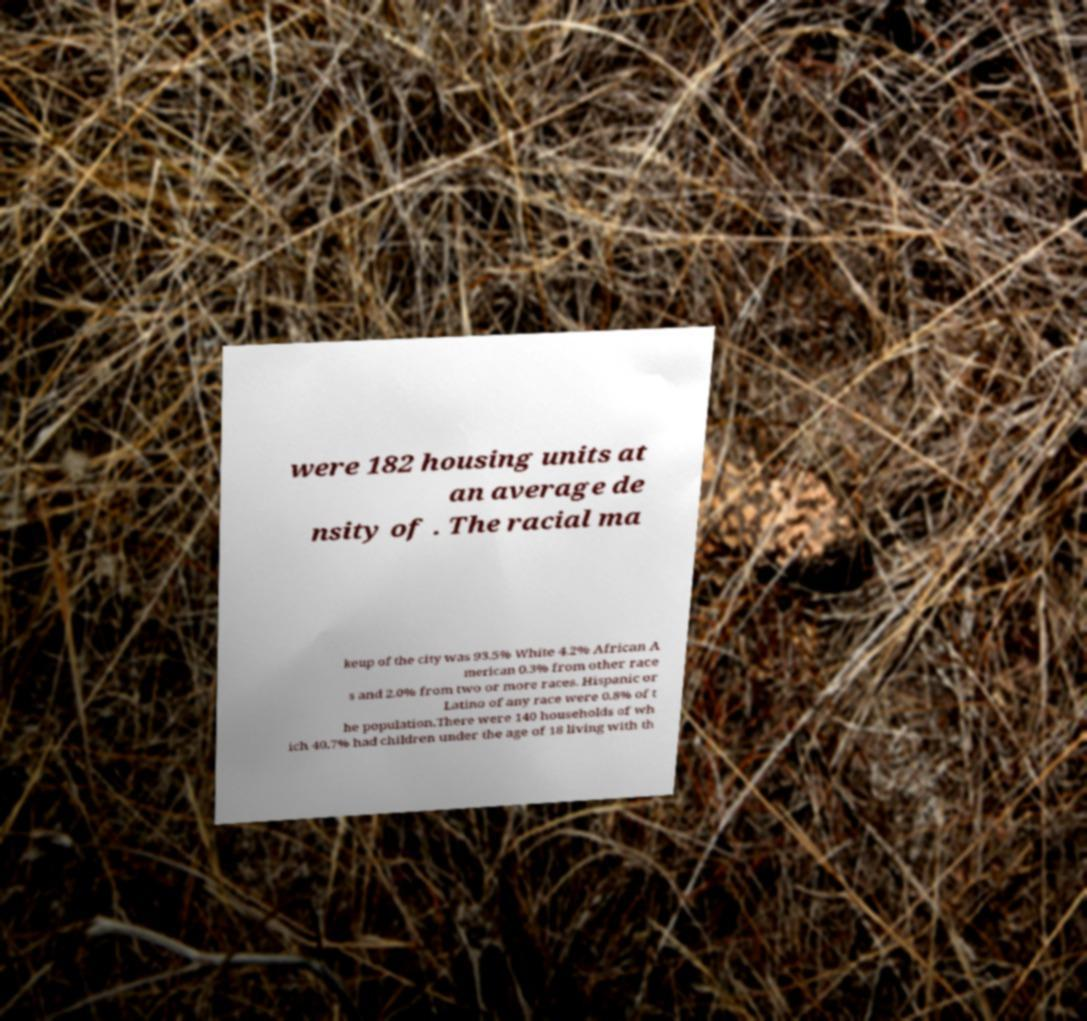Please identify and transcribe the text found in this image. were 182 housing units at an average de nsity of . The racial ma keup of the city was 93.5% White 4.2% African A merican 0.3% from other race s and 2.0% from two or more races. Hispanic or Latino of any race were 0.8% of t he population.There were 140 households of wh ich 40.7% had children under the age of 18 living with th 